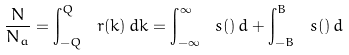Convert formula to latex. <formula><loc_0><loc_0><loc_500><loc_500>\frac { N } { N _ { a } } = \int _ { - Q } ^ { Q } \ r ( k ) \, d k = \int _ { - \infty } ^ { \infty } \ s ( \L ) \, d \L + \int _ { - B } ^ { B } \ s ( \L ) \, d \L \,</formula> 